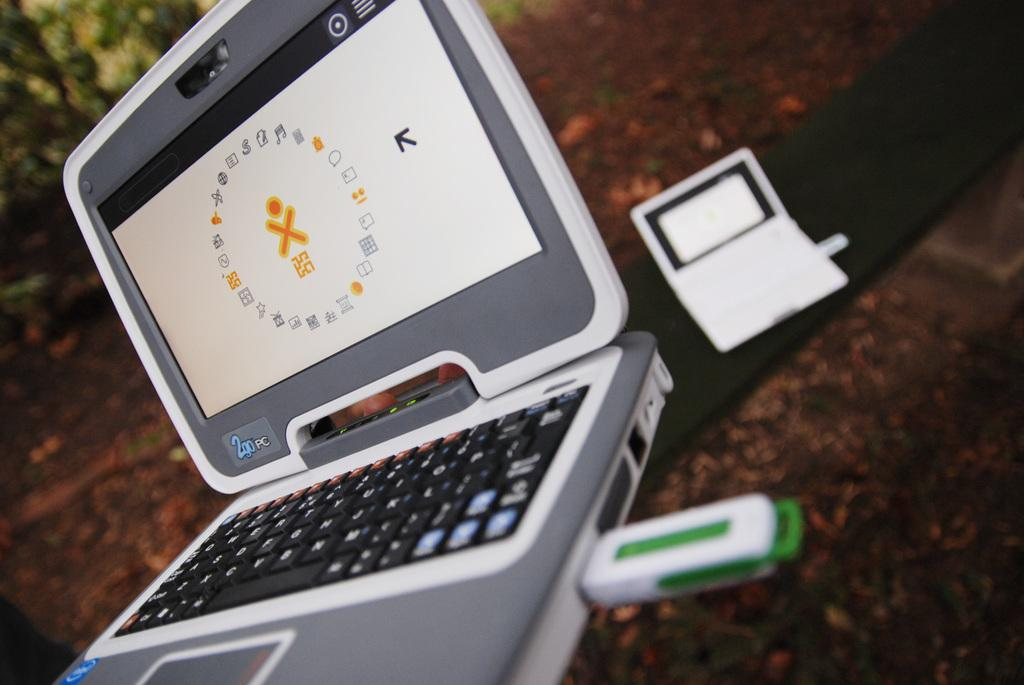<image>
Write a terse but informative summary of the picture. A series of symbols are displayed on a 2go Pc. 